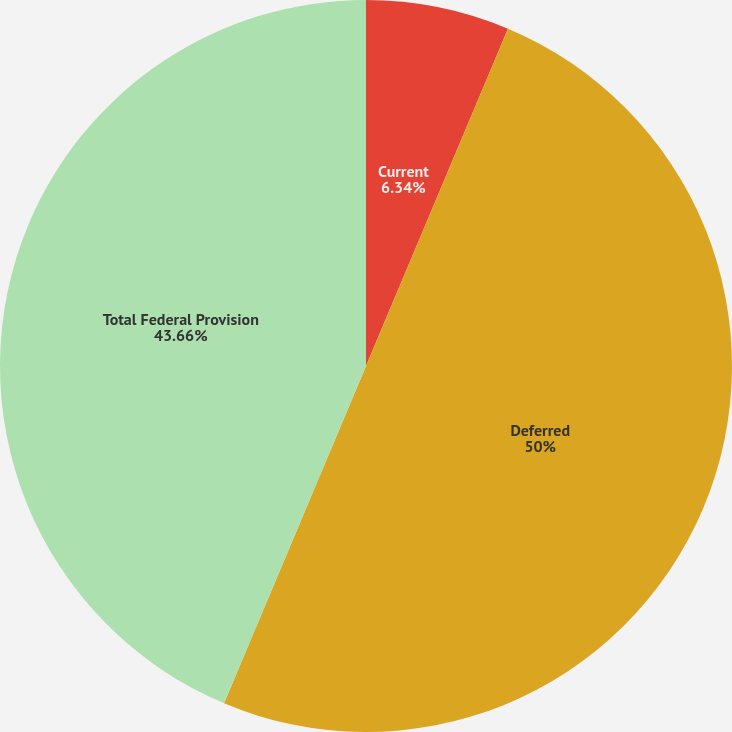Convert chart. <chart><loc_0><loc_0><loc_500><loc_500><pie_chart><fcel>Current<fcel>Deferred<fcel>Total Federal Provision<nl><fcel>6.34%<fcel>50.0%<fcel>43.66%<nl></chart> 